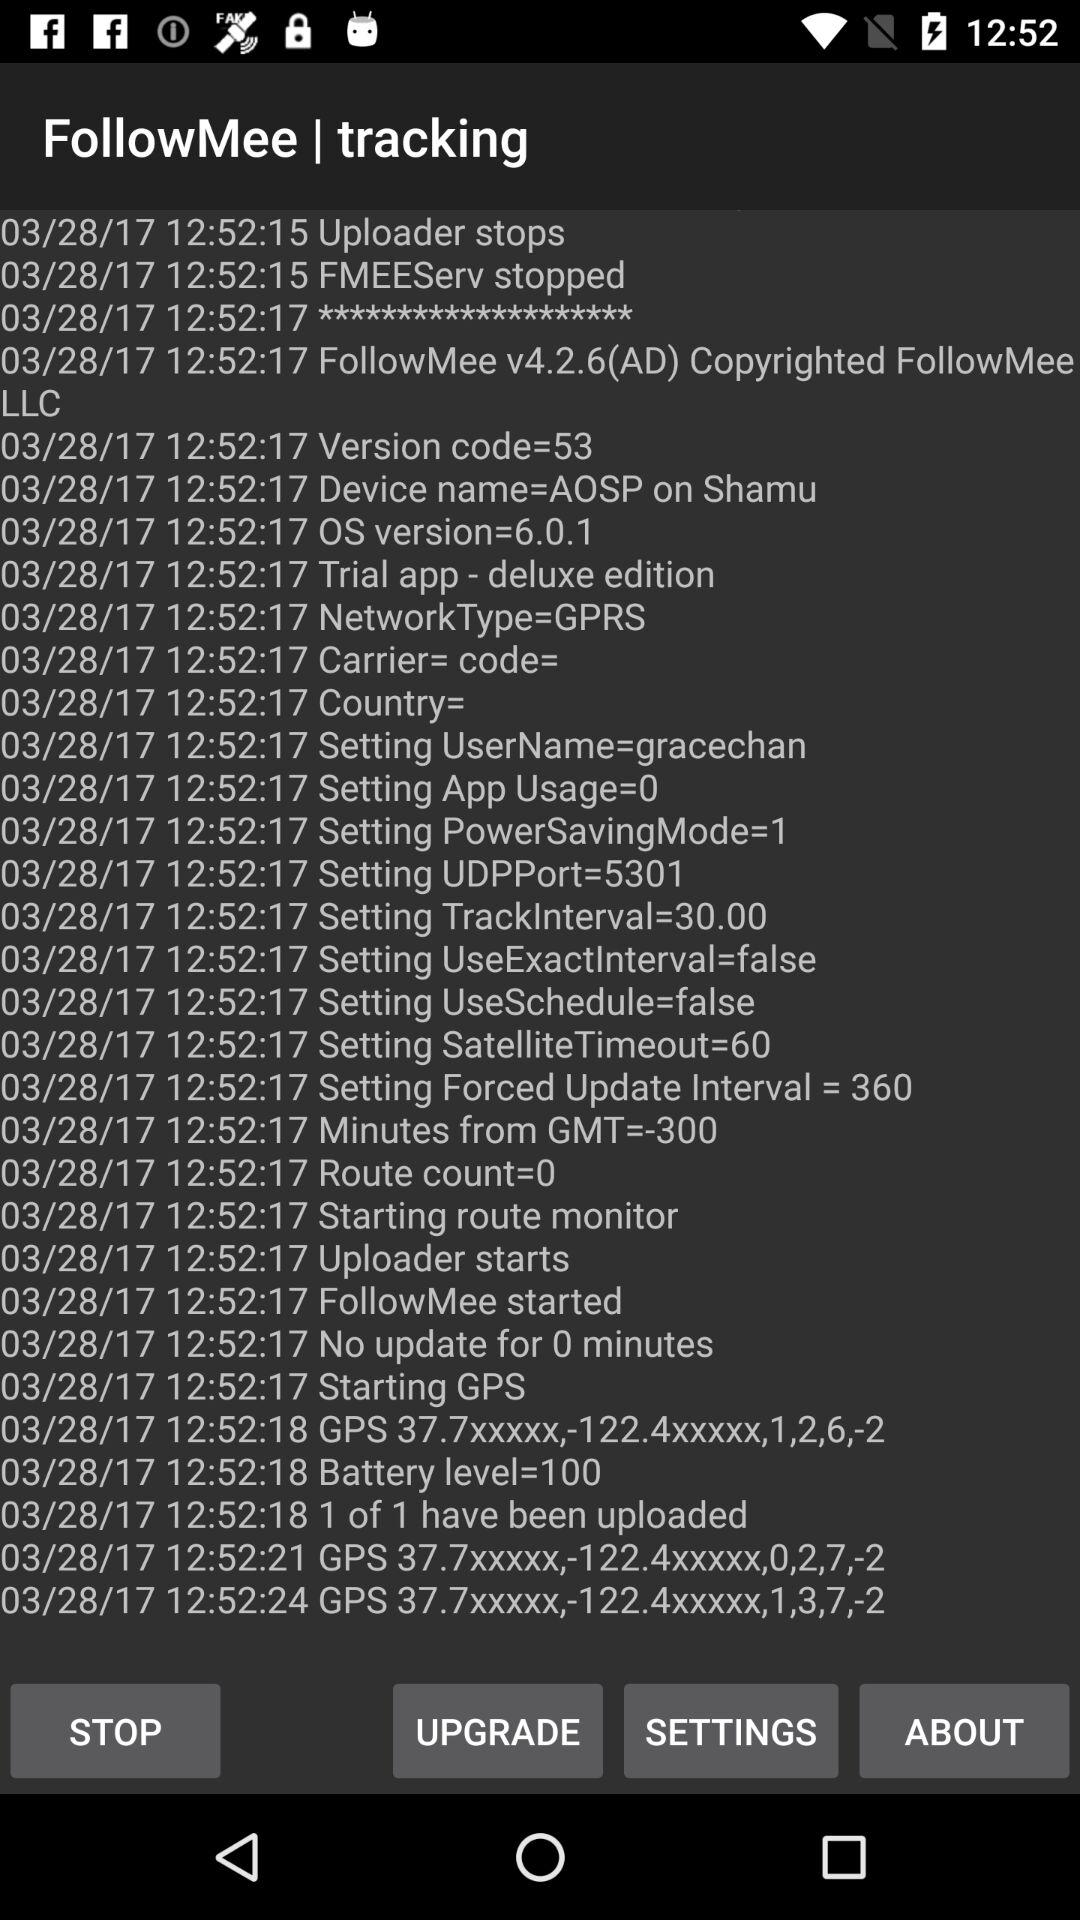What's the device name? The device name is AOSP on Shamu. 